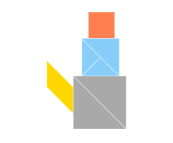Desribe the image The image shows geometric shapes arranged together to form an abstract composition. The shapes include a yellow rectangle at the bottom, a light blue square stacked on top of it, and an orange square placed above the blue square. To the right of the vertical stack is a gray triangle pointing towards the right.

The shapes are solid colors with clean lines and edges, giving the composition a minimalist and modern aesthetic. The combination of basic geometric forms in bright, contrasting colors creates a visually striking and eye-catching design. 